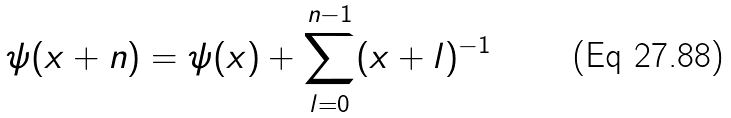Convert formula to latex. <formula><loc_0><loc_0><loc_500><loc_500>\psi ( x + n ) = \psi ( x ) + \sum _ { l = 0 } ^ { n - 1 } ( x + l ) ^ { - 1 }</formula> 